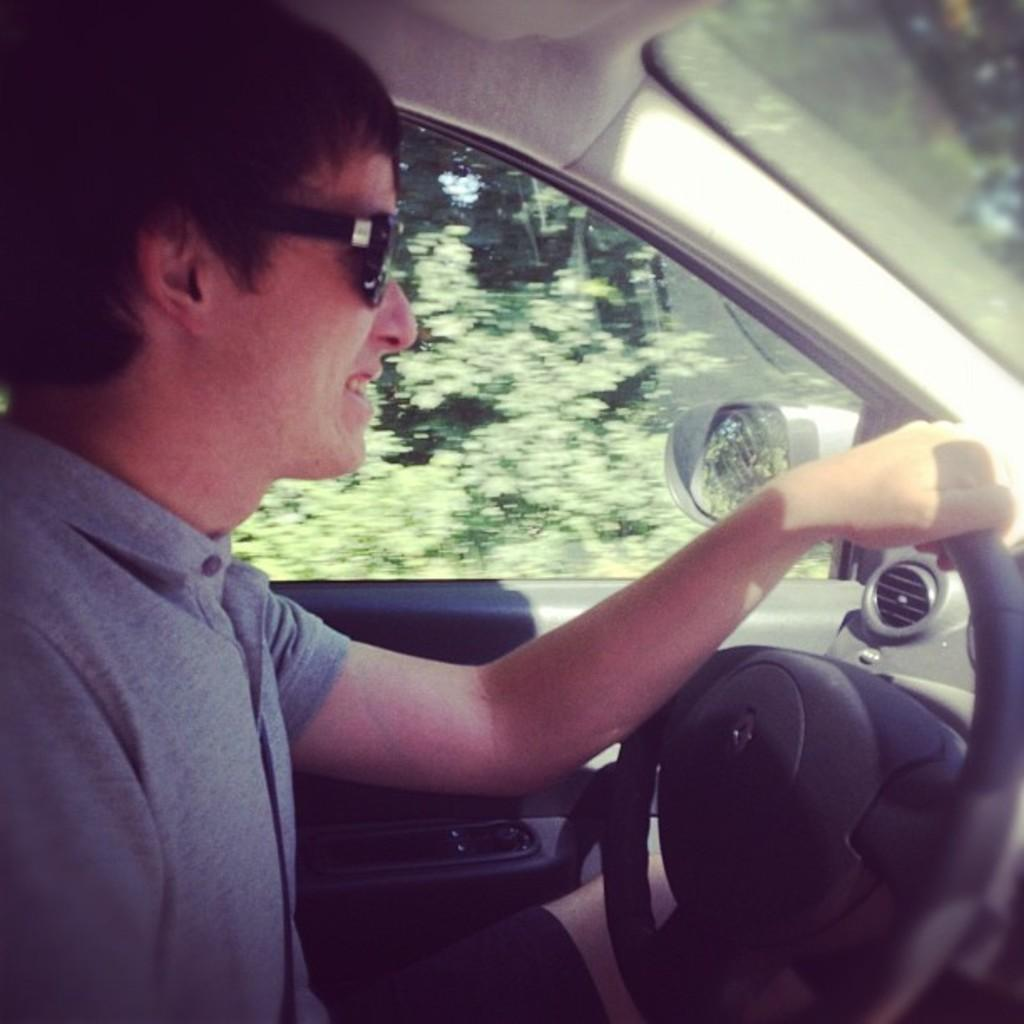Who is present in the image? There is a man in the image. What is the man wearing? The man is wearing glasses (specs). What is the man holding in the image? The man is holding a steering wheel. What type of vehicle might the steering wheel belong to? The steering wheel is likely from a car. What can be seen in the background of the image? There are trees visible in the background of the image. How does the man measure the amusement level of the road in the image? There is no indication in the image that the man is measuring the amusement level of the road, and the image does not show a road. 